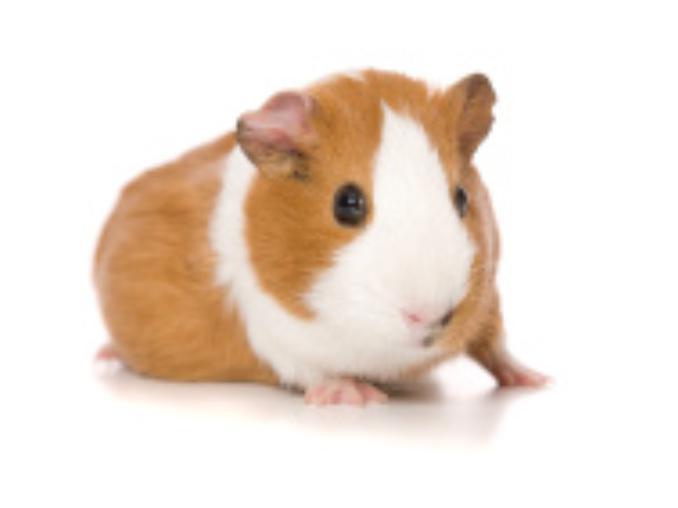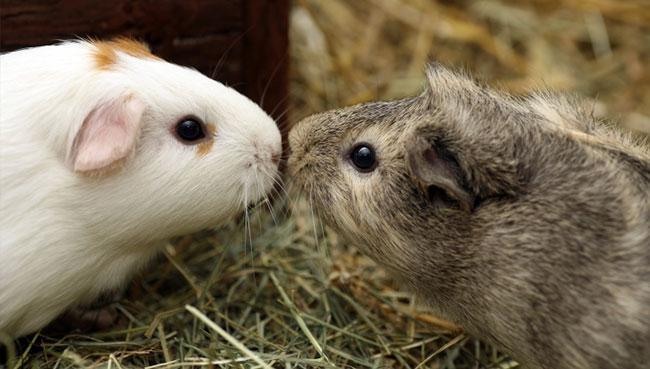The first image is the image on the left, the second image is the image on the right. Given the left and right images, does the statement "One of the guinea pigs has patches of dark brown, black, and white fur." hold true? Answer yes or no. No. 